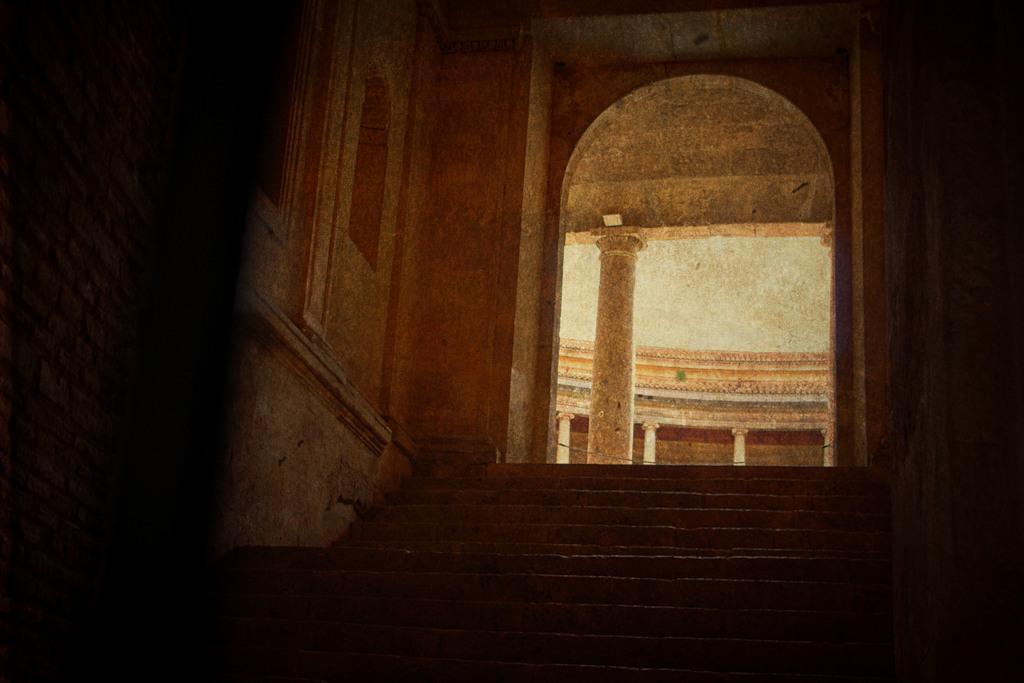In one or two sentences, can you explain what this image depicts? In this image I can see stairs in the front. There is an arch in the center, there are pillars at the back. There is a window on the left. 